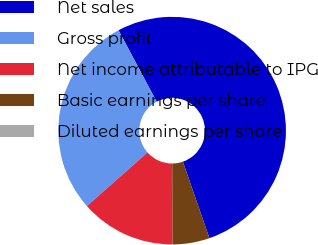Convert chart. <chart><loc_0><loc_0><loc_500><loc_500><pie_chart><fcel>Net sales<fcel>Gross profit<fcel>Net income attributable to IPG<fcel>Basic earnings per share<fcel>Diluted earnings per share<nl><fcel>52.49%<fcel>28.73%<fcel>13.53%<fcel>5.25%<fcel>0.0%<nl></chart> 